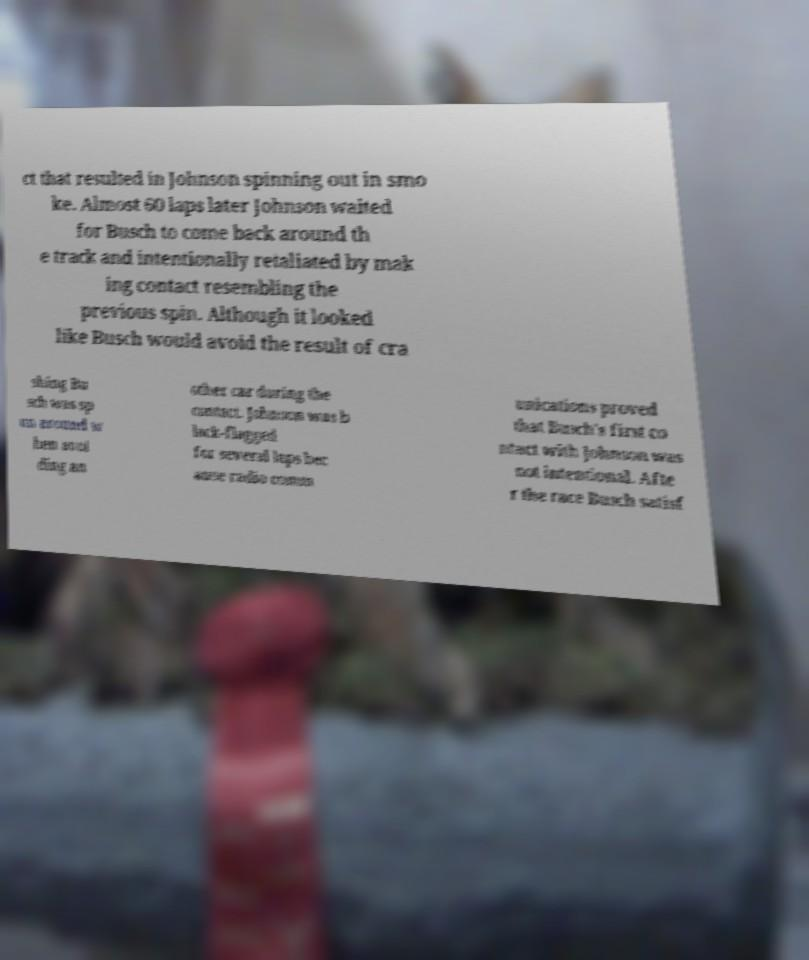Could you extract and type out the text from this image? ct that resulted in Johnson spinning out in smo ke. Almost 60 laps later Johnson waited for Busch to come back around th e track and intentionally retaliated by mak ing contact resembling the previous spin. Although it looked like Busch would avoid the result of cra shing Bu sch was sp un around w hen avoi ding an other car during the contact. Johnson was b lack-flagged for several laps bec ause radio comm unications proved that Busch's first co ntact with Johnson was not intentional. Afte r the race Busch satisf 